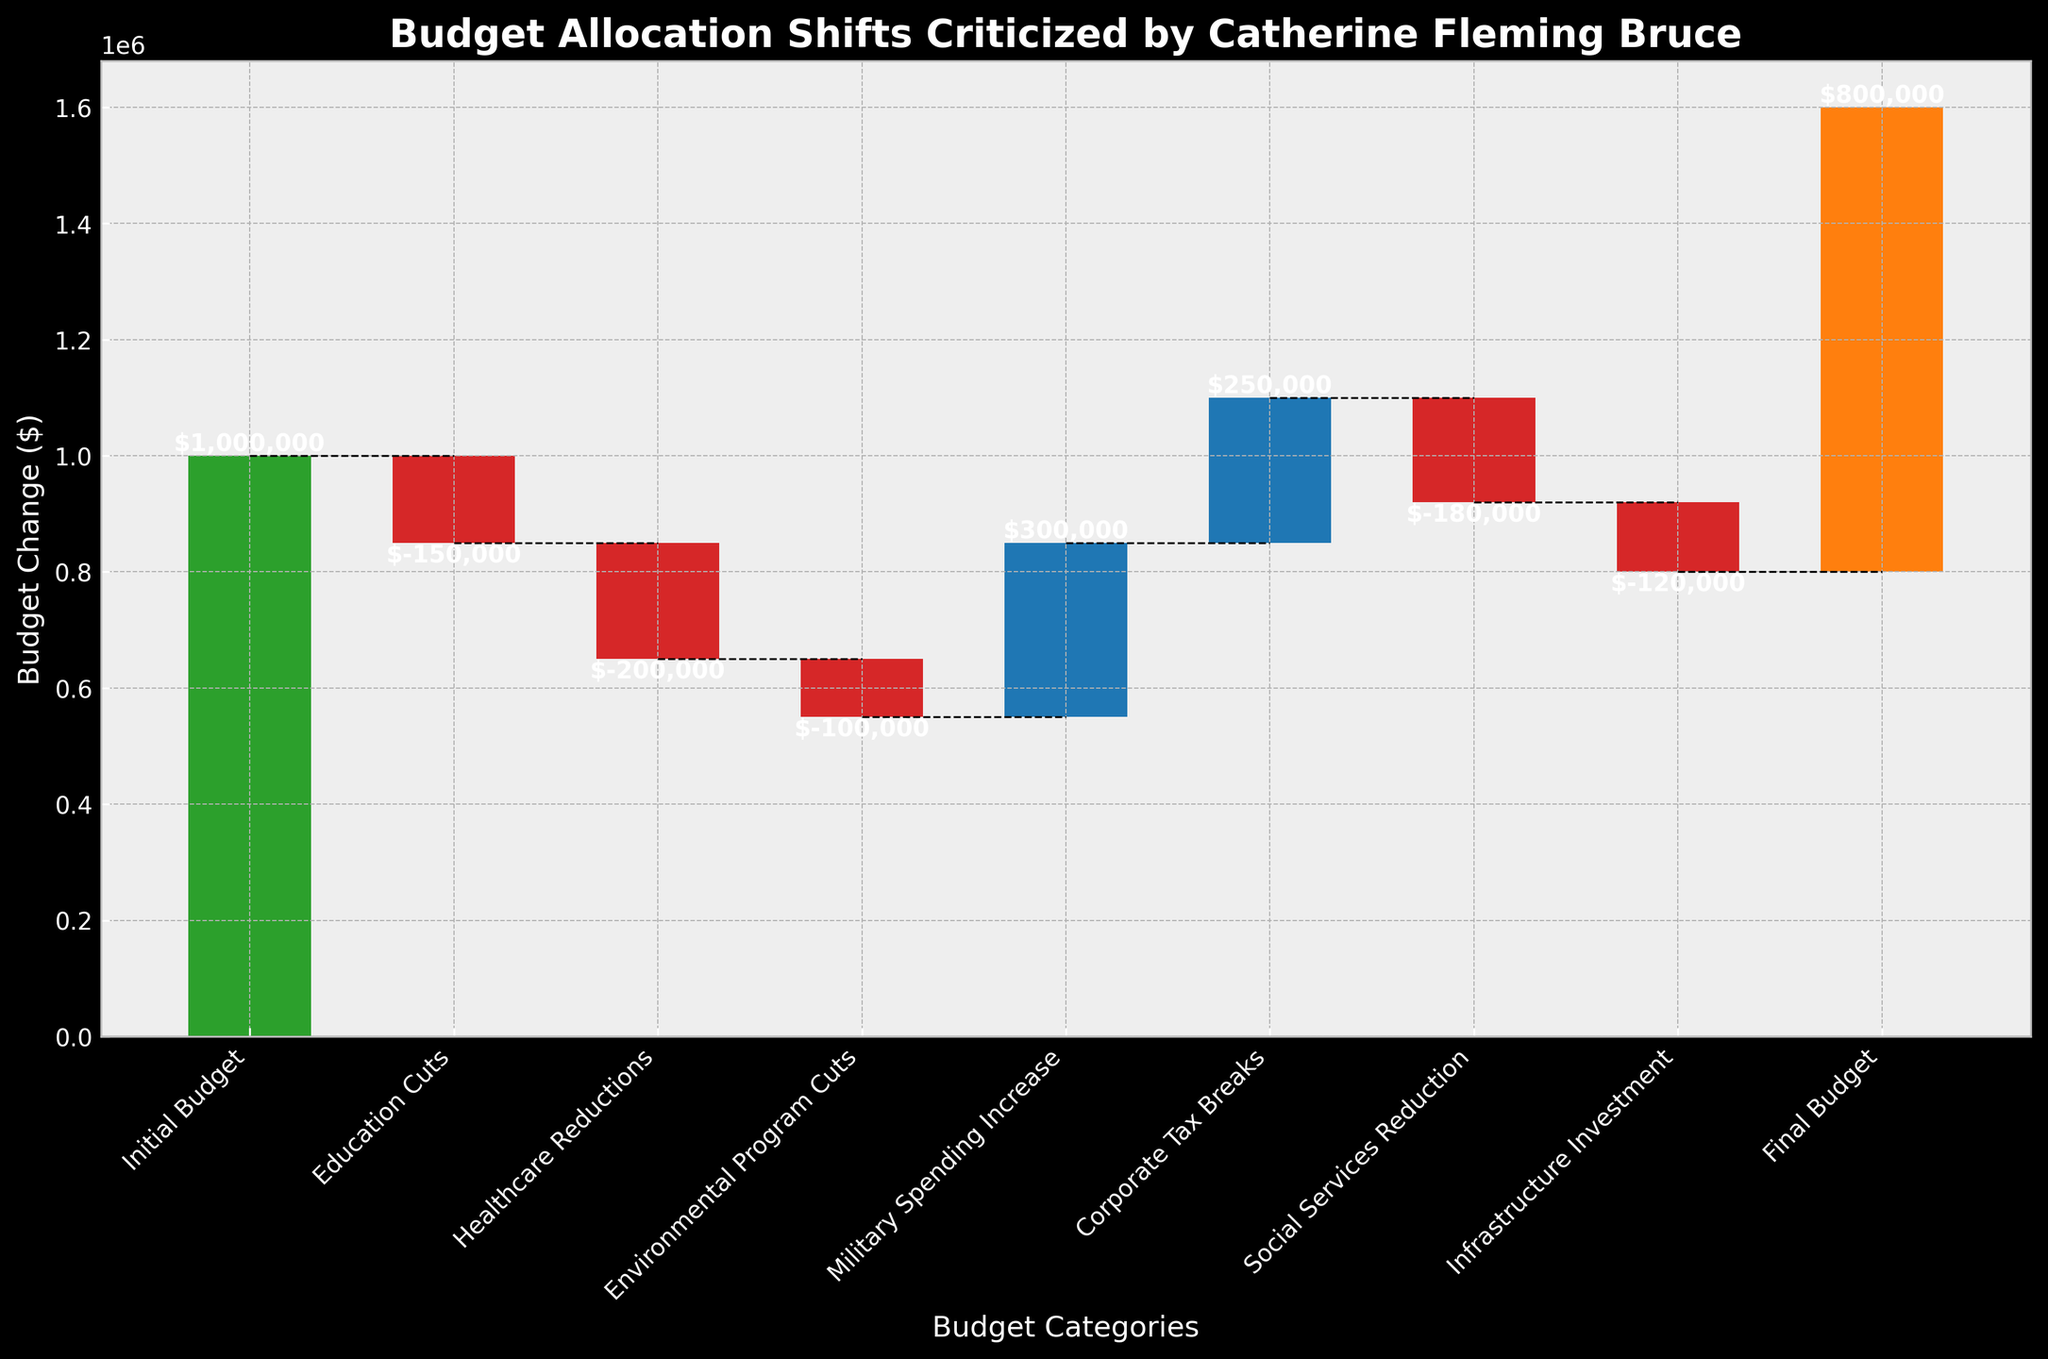What is the title of the chart? The title is usually displayed at the top of the chart and specifies the subject matter. In this case, the title is "Budget Allocation Shifts Criticized by Catherine Fleming Bruce".
Answer: Budget Allocation Shifts Criticized by Catherine Fleming Bruce What color represents the Initial Budget bar? The colors of the bars are visually distinguishable. The Initial Budget bar is marked in green.
Answer: Green How much was the budget reduced in the Healthcare category? The bar labeled "Healthcare Reductions" with a negative value represents the reduction. The amount is -$200,000.
Answer: -$200,000 What is the final budget, as shown in the chart? The final budget is represented by the bar labeled "Final Budget". The value at this point is $800,000.
Answer: 800,000 Which category had the highest budget increase? Among all the positive values, the "Military Spending Increase" bar represents the highest budget increase, which is $300,000.
Answer: Military Spending Increase What is the cumulative budget change after the Education Cuts? The cumulative budget change is calculated by summing the Initial Budget and the value of Education Cuts. The Initial Budget is $1,000,000, and Education Cuts are -$150,000. So, $1,000,000 - $150,000 = $850,000.
Answer: 850,000 How much more was the budget reduced for Social Services compared to Education? Subtract the Education Cuts from Social Services Reduction: -$180,000 - (-$150,000) = -$180,000 + $150,000 = -$30,000.
Answer: $30,000 Which category had the smallest budget cut? Identify all the negative values and pick the smallest in magnitude. The "Environmental Program Cuts" had the smallest cut with -$100,000.
Answer: Environmental Program Cuts What is the net change in the budget after accounting for all shifts? The net change is the difference between the Initial Budget and the Final Budget. Initial Budget is $1,000,000 and the Final Budget is $800,000. So, $1,000,000 - $800,000 = $200,000.
Answer: -$200,000 Which connections between bars reflect zero change in cumulative budget value? Connecting lines that remain horizontal indicate zero change. There is no category where the cumulative value does not change between two successive categories.
Answer: None 